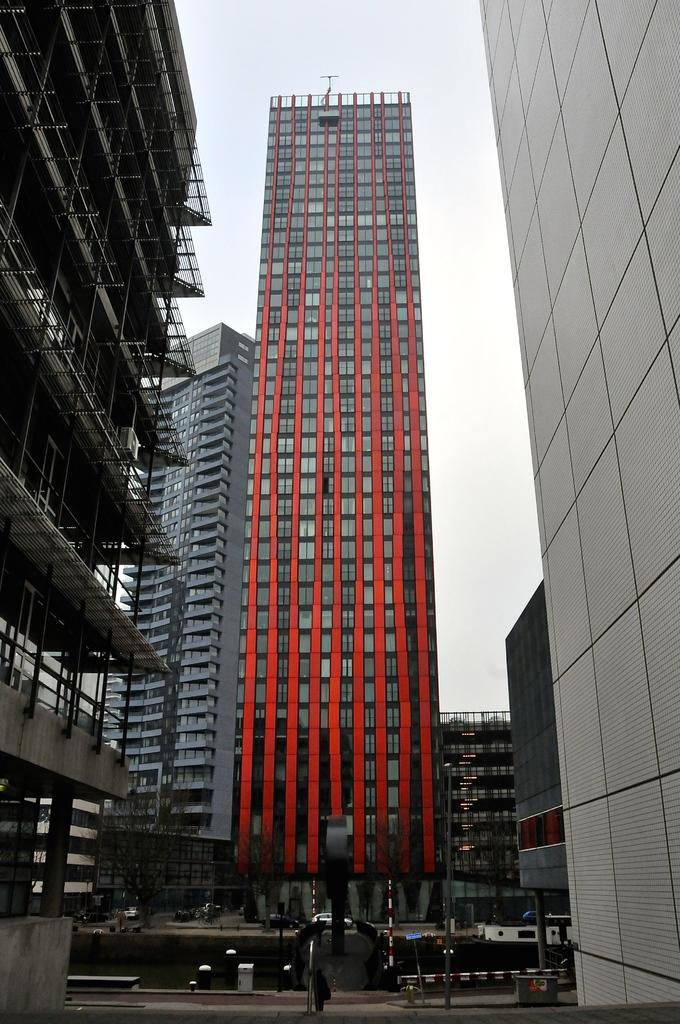What type of structures can be seen in the image? There are buildings in the image. What material is used for the rods that are visible? Metal rods are visible in the image. What type of plant is present in the image? There is a tree in the image. What type of transportation is depicted in the image? Vehicles are present in the image. What type of pain is the tree experiencing in the image? There is no indication of pain in the image; the tree is a plant and does not experience pain. Can you see any zippers on the vehicles in the image? There are no zippers present in the image; zippers are typically found on clothing or bags, not vehicles. 